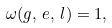Convert formula to latex. <formula><loc_0><loc_0><loc_500><loc_500>\omega ( g , \, e , \, l ) = 1 ,</formula> 